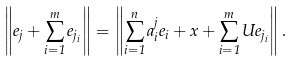<formula> <loc_0><loc_0><loc_500><loc_500>\left \| e _ { j } + \sum _ { i = 1 } ^ { m } e _ { j _ { i } } \right \| = \left \| \sum _ { i = 1 } ^ { n } a ^ { j } _ { i } e _ { i } + x + \sum _ { i = 1 } ^ { m } U e _ { j _ { i } } \right \| .</formula> 